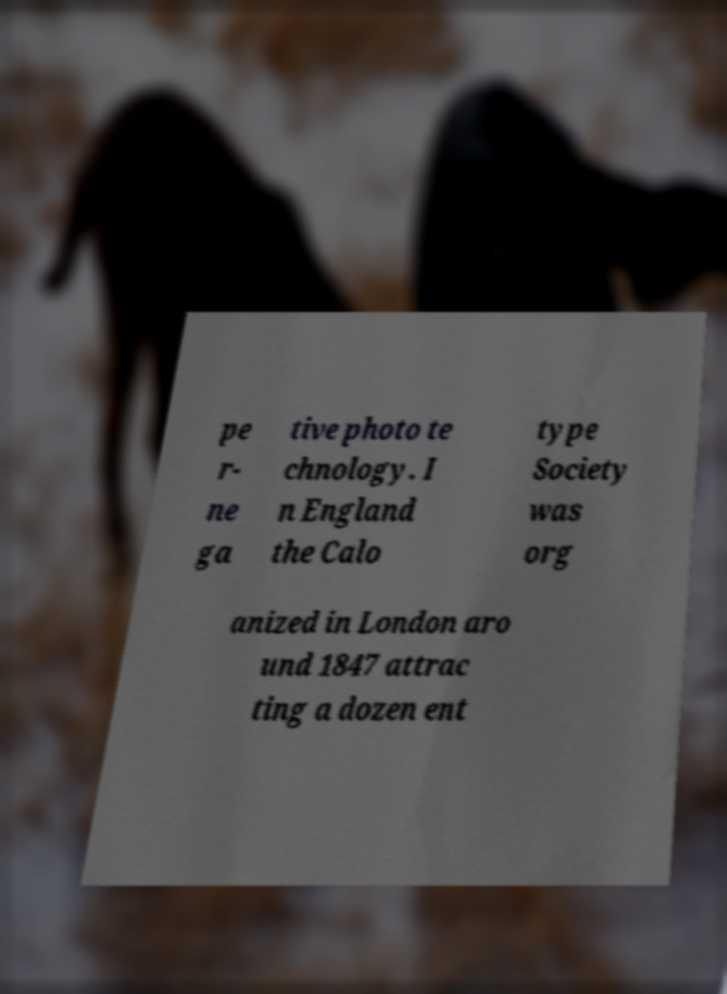Can you accurately transcribe the text from the provided image for me? pe r- ne ga tive photo te chnology. I n England the Calo type Society was org anized in London aro und 1847 attrac ting a dozen ent 